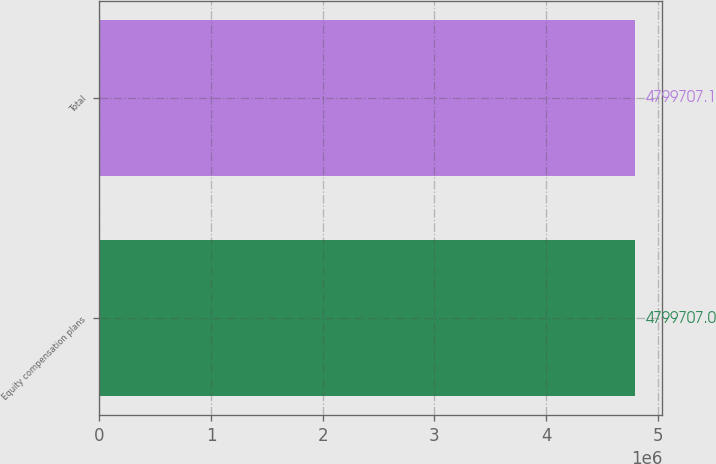Convert chart. <chart><loc_0><loc_0><loc_500><loc_500><bar_chart><fcel>Equity compensation plans<fcel>Total<nl><fcel>4.79971e+06<fcel>4.79971e+06<nl></chart> 